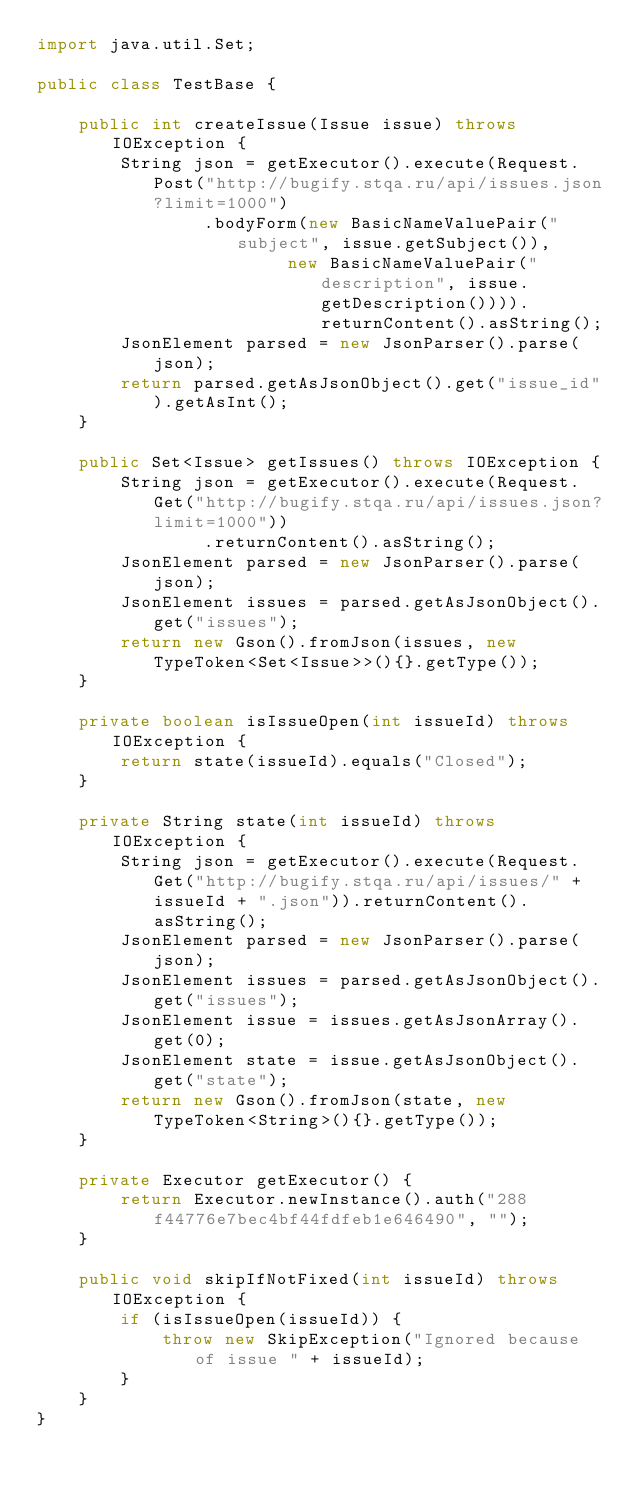Convert code to text. <code><loc_0><loc_0><loc_500><loc_500><_Java_>import java.util.Set;

public class TestBase {

    public int createIssue(Issue issue) throws IOException {
        String json = getExecutor().execute(Request.Post("http://bugify.stqa.ru/api/issues.json?limit=1000")
                .bodyForm(new BasicNameValuePair("subject", issue.getSubject()),
                        new BasicNameValuePair("description", issue.getDescription()))).returnContent().asString();
        JsonElement parsed = new JsonParser().parse(json);
        return parsed.getAsJsonObject().get("issue_id").getAsInt();
    }

    public Set<Issue> getIssues() throws IOException {
        String json = getExecutor().execute(Request.Get("http://bugify.stqa.ru/api/issues.json?limit=1000"))
                .returnContent().asString();
        JsonElement parsed = new JsonParser().parse(json);
        JsonElement issues = parsed.getAsJsonObject().get("issues");
        return new Gson().fromJson(issues, new TypeToken<Set<Issue>>(){}.getType());
    }

    private boolean isIssueOpen(int issueId) throws IOException {
        return state(issueId).equals("Closed");
    }

    private String state(int issueId) throws IOException {
        String json = getExecutor().execute(Request.Get("http://bugify.stqa.ru/api/issues/" + issueId + ".json")).returnContent().asString();
        JsonElement parsed = new JsonParser().parse(json);
        JsonElement issues = parsed.getAsJsonObject().get("issues");
        JsonElement issue = issues.getAsJsonArray().get(0);
        JsonElement state = issue.getAsJsonObject().get("state");
        return new Gson().fromJson(state, new TypeToken<String>(){}.getType());
    }

    private Executor getExecutor() {
        return Executor.newInstance().auth("288f44776e7bec4bf44fdfeb1e646490", "");
    }

    public void skipIfNotFixed(int issueId) throws IOException {
        if (isIssueOpen(issueId)) {
            throw new SkipException("Ignored because of issue " + issueId);
        }
    }
}
</code> 